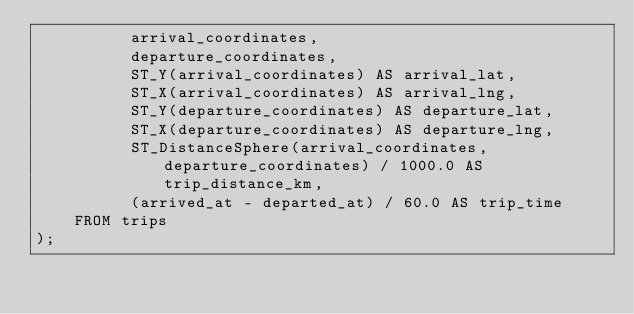Convert code to text. <code><loc_0><loc_0><loc_500><loc_500><_SQL_>          arrival_coordinates,
          departure_coordinates,
          ST_Y(arrival_coordinates) AS arrival_lat,
          ST_X(arrival_coordinates) AS arrival_lng,
          ST_Y(departure_coordinates) AS departure_lat,
          ST_X(departure_coordinates) AS departure_lng,
          ST_DistanceSphere(arrival_coordinates, departure_coordinates) / 1000.0 AS trip_distance_km,
          (arrived_at - departed_at) / 60.0 AS trip_time
   	FROM trips
);
</code> 